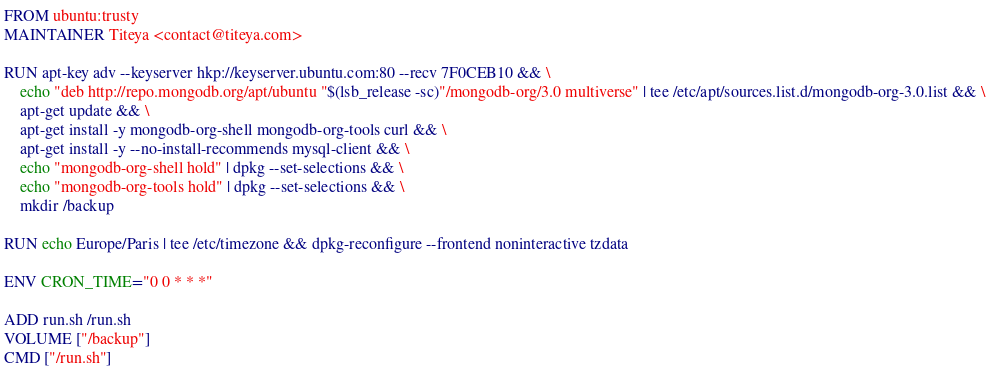<code> <loc_0><loc_0><loc_500><loc_500><_Dockerfile_>FROM ubuntu:trusty
MAINTAINER Titeya <contact@titeya.com>

RUN apt-key adv --keyserver hkp://keyserver.ubuntu.com:80 --recv 7F0CEB10 && \
    echo "deb http://repo.mongodb.org/apt/ubuntu "$(lsb_release -sc)"/mongodb-org/3.0 multiverse" | tee /etc/apt/sources.list.d/mongodb-org-3.0.list && \
    apt-get update && \
    apt-get install -y mongodb-org-shell mongodb-org-tools curl && \
    apt-get install -y --no-install-recommends mysql-client && \
    echo "mongodb-org-shell hold" | dpkg --set-selections && \
    echo "mongodb-org-tools hold" | dpkg --set-selections && \
    mkdir /backup

RUN echo Europe/Paris | tee /etc/timezone && dpkg-reconfigure --frontend noninteractive tzdata

ENV CRON_TIME="0 0 * * *"

ADD run.sh /run.sh
VOLUME ["/backup"]
CMD ["/run.sh"]
</code> 